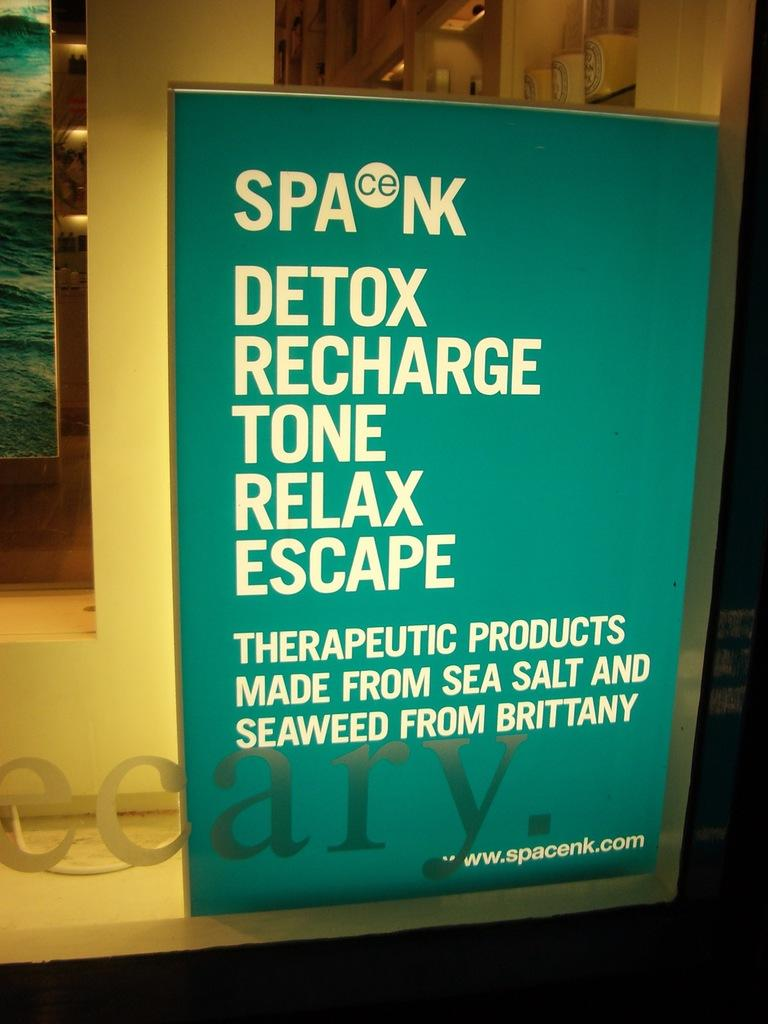<image>
Relay a brief, clear account of the picture shown. A sign for Spacenk advertising their therapeutic products. 